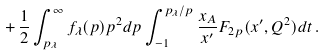Convert formula to latex. <formula><loc_0><loc_0><loc_500><loc_500>+ \, \frac { 1 } { 2 } \int _ { p _ { \lambda } } ^ { \infty } f _ { \lambda } ( p ) p ^ { 2 } d p \int ^ { p _ { \lambda } / p } _ { - 1 } \frac { x _ { A } } { x ^ { \prime } } F _ { 2 p } ( x ^ { \prime } , Q ^ { 2 } ) d t \, .</formula> 